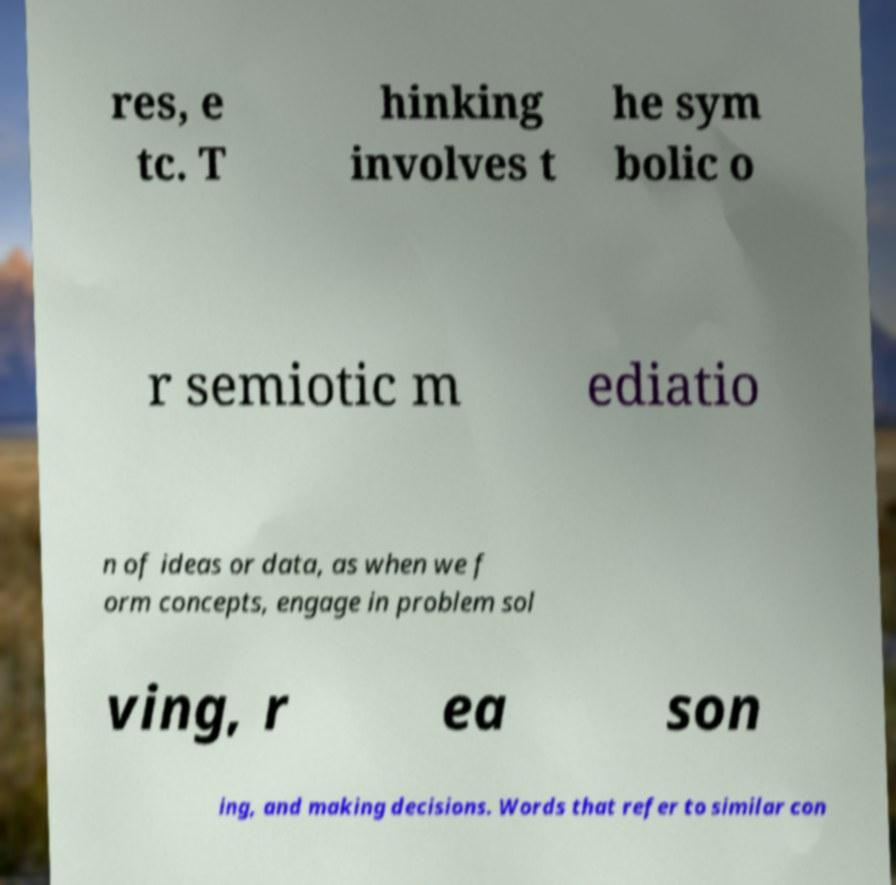Could you assist in decoding the text presented in this image and type it out clearly? res, e tc. T hinking involves t he sym bolic o r semiotic m ediatio n of ideas or data, as when we f orm concepts, engage in problem sol ving, r ea son ing, and making decisions. Words that refer to similar con 